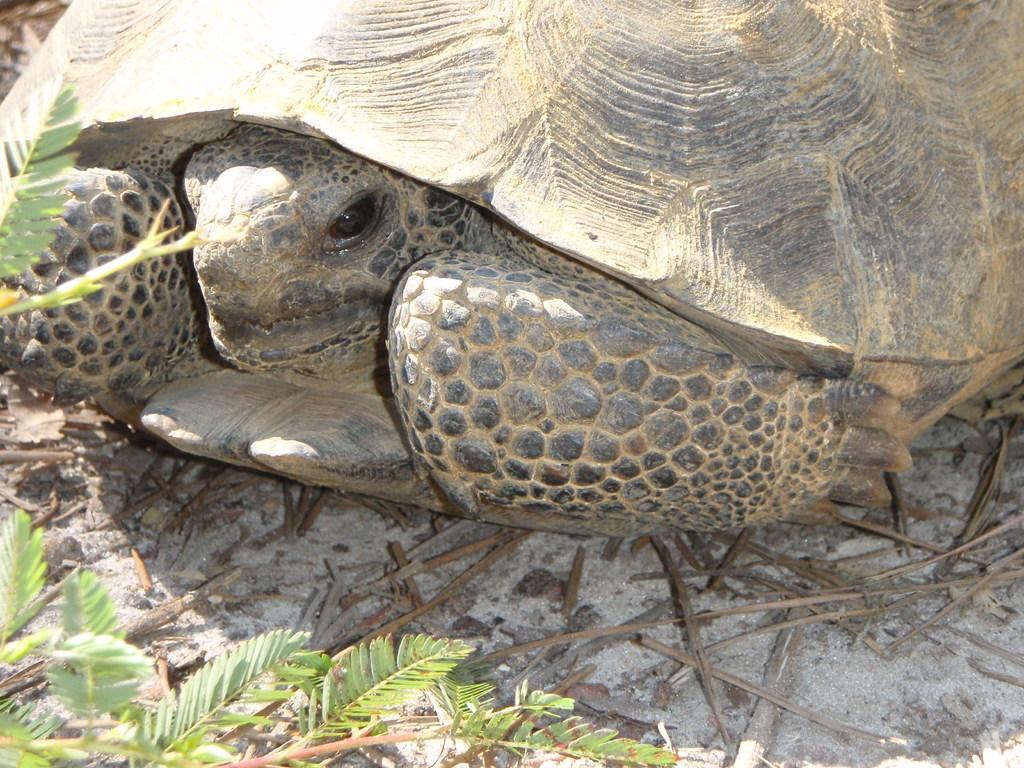Could you give a brief overview of what you see in this image? In this image we can see a tortoise on the ground and plants. 